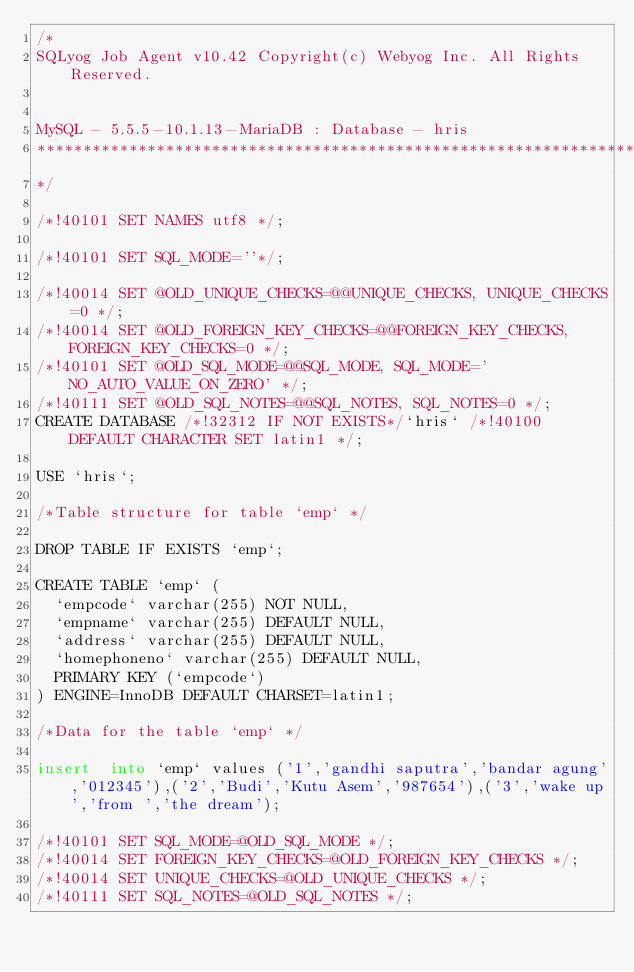<code> <loc_0><loc_0><loc_500><loc_500><_SQL_>/*
SQLyog Job Agent v10.42 Copyright(c) Webyog Inc. All Rights Reserved.


MySQL - 5.5.5-10.1.13-MariaDB : Database - hris
*********************************************************************
*/

/*!40101 SET NAMES utf8 */;

/*!40101 SET SQL_MODE=''*/;

/*!40014 SET @OLD_UNIQUE_CHECKS=@@UNIQUE_CHECKS, UNIQUE_CHECKS=0 */;
/*!40014 SET @OLD_FOREIGN_KEY_CHECKS=@@FOREIGN_KEY_CHECKS, FOREIGN_KEY_CHECKS=0 */;
/*!40101 SET @OLD_SQL_MODE=@@SQL_MODE, SQL_MODE='NO_AUTO_VALUE_ON_ZERO' */;
/*!40111 SET @OLD_SQL_NOTES=@@SQL_NOTES, SQL_NOTES=0 */;
CREATE DATABASE /*!32312 IF NOT EXISTS*/`hris` /*!40100 DEFAULT CHARACTER SET latin1 */;

USE `hris`;

/*Table structure for table `emp` */

DROP TABLE IF EXISTS `emp`;

CREATE TABLE `emp` (
  `empcode` varchar(255) NOT NULL,
  `empname` varchar(255) DEFAULT NULL,
  `address` varchar(255) DEFAULT NULL,
  `homephoneno` varchar(255) DEFAULT NULL,
  PRIMARY KEY (`empcode`)
) ENGINE=InnoDB DEFAULT CHARSET=latin1;

/*Data for the table `emp` */

insert  into `emp` values ('1','gandhi saputra','bandar agung','012345'),('2','Budi','Kutu Asem','987654'),('3','wake up','from ','the dream');

/*!40101 SET SQL_MODE=@OLD_SQL_MODE */;
/*!40014 SET FOREIGN_KEY_CHECKS=@OLD_FOREIGN_KEY_CHECKS */;
/*!40014 SET UNIQUE_CHECKS=@OLD_UNIQUE_CHECKS */;
/*!40111 SET SQL_NOTES=@OLD_SQL_NOTES */;
</code> 